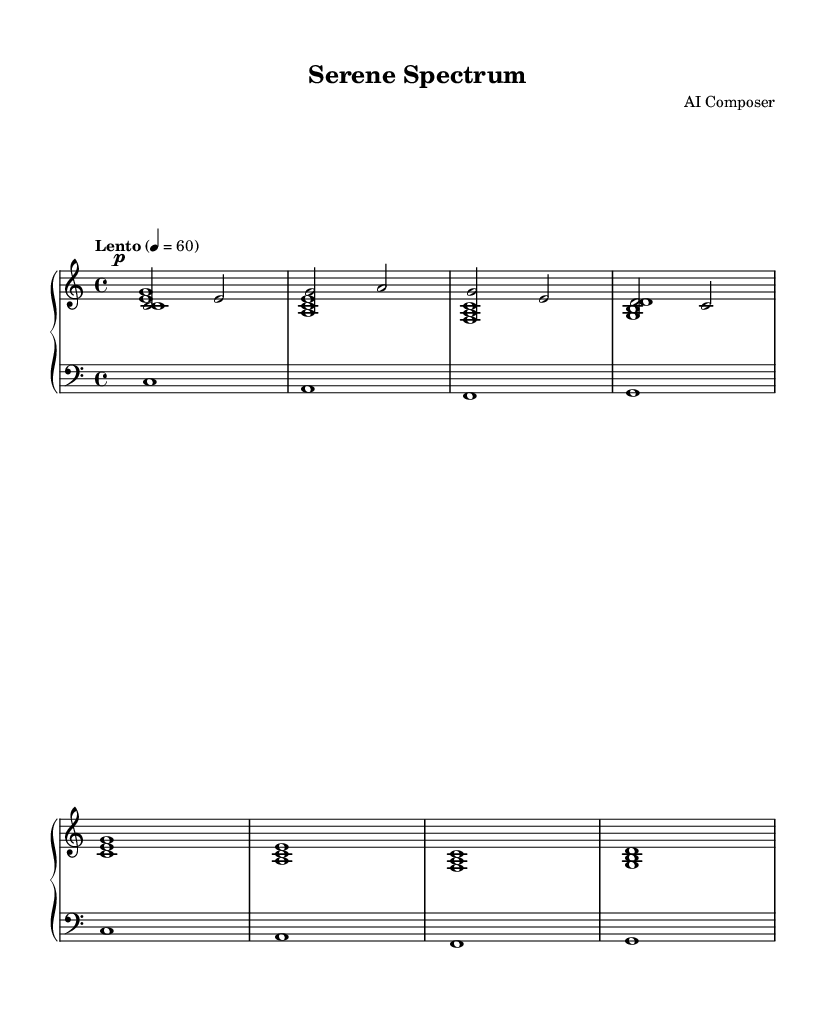What is the key signature of this music? The key signature is C major, which has no sharps or flats.
Answer: C major What is the time signature of this music? The time signature is indicated at the beginning of the score as 4/4, meaning there are four beats in each measure.
Answer: 4/4 What is the tempo marking for the piece? The tempo marking shows "Lento" which indicates a slow pace, typically around 60 beats per minute.
Answer: Lento How many measures are in the score? By counting the measures in the upper staff, there are a total of eight measures present in the music.
Answer: Eight What is the dynamic marking for the melody? The dynamic marking indicates that the melody should be played at a soft volume, marked as 'p' (piano).
Answer: Piano What chords are played in the upper staff? Observing the notes in the upper staff, the chords played are C major, A minor, F major, and G major, each spanning one measure.
Answer: C, A minor, F, G How does the rhythm of the lower staff compare to the upper staff? The lower staff consists of whole notes being held for an entire measure, contrasting with the more varied rhythm and shorter note values in the upper staff.
Answer: Whole notes 